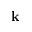<formula> <loc_0><loc_0><loc_500><loc_500>{ k }</formula> 